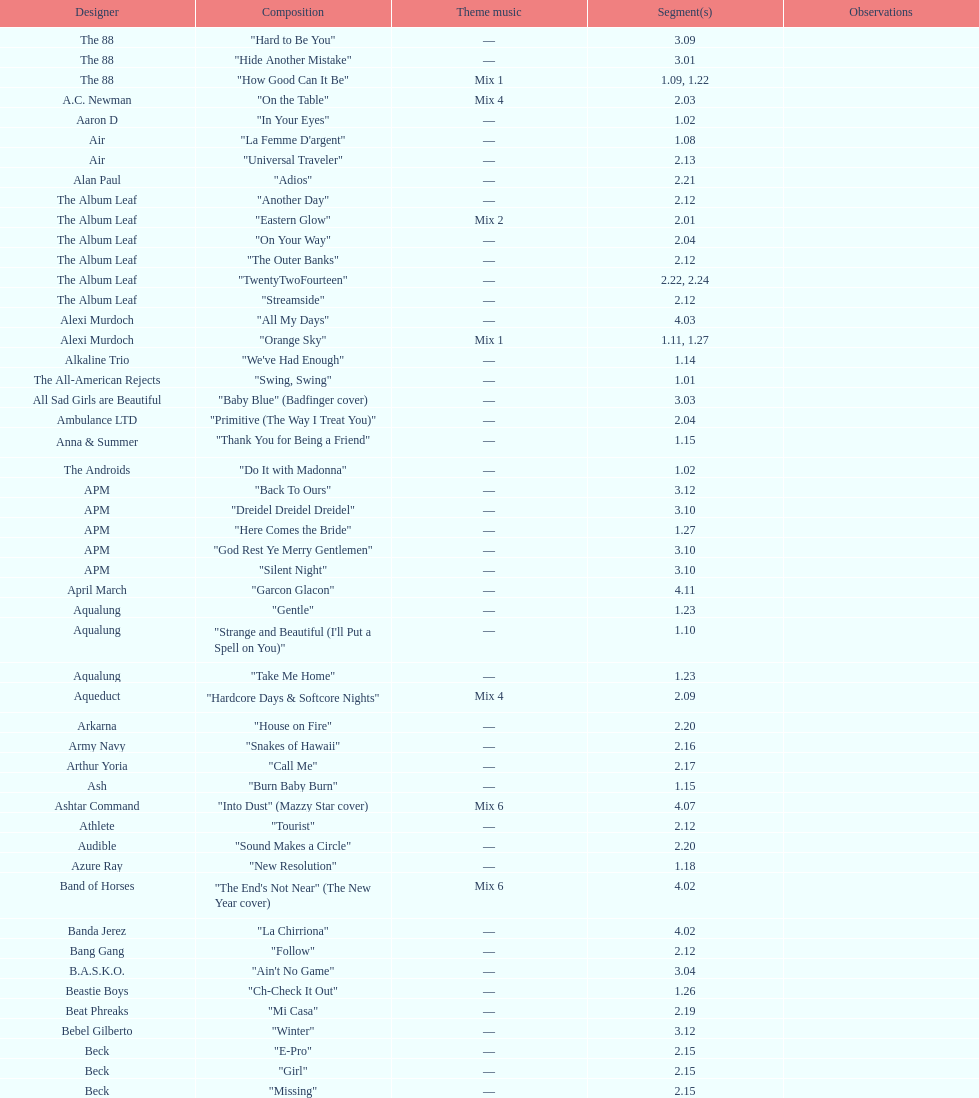The artist ash only had one song that appeared in the o.c. what is the name of that song? "Burn Baby Burn". 